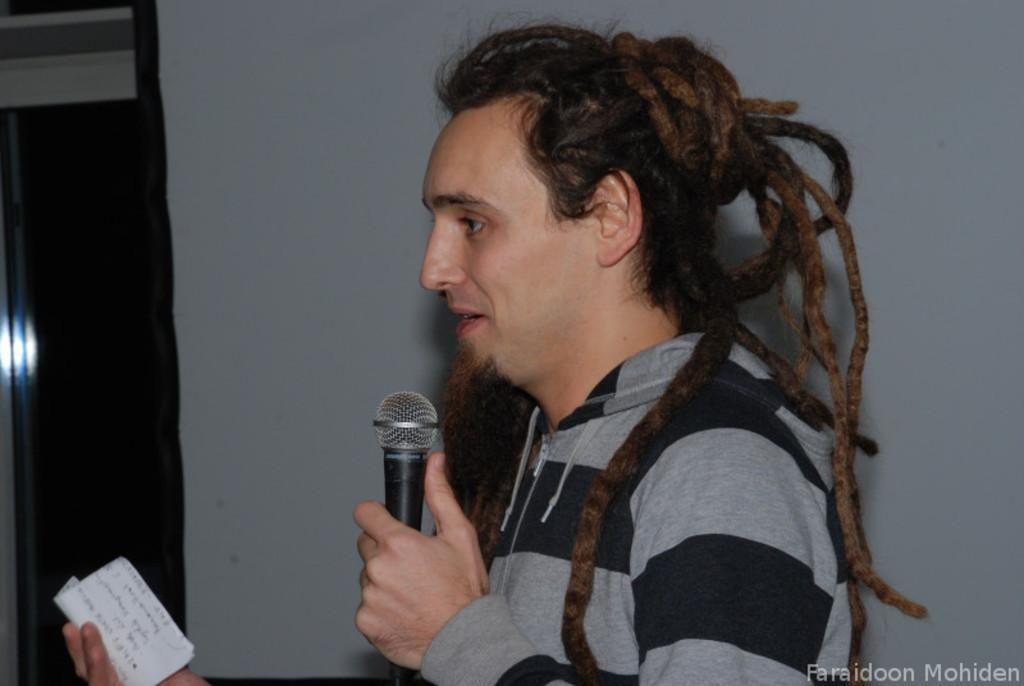Describe this image in one or two sentences. There is a person holding a mic and paper. In the background there is a wall. 